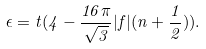<formula> <loc_0><loc_0><loc_500><loc_500>\epsilon = t ( 4 - \frac { 1 6 \pi } { \sqrt { 3 } } | f | ( n + \frac { 1 } { 2 } ) ) .</formula> 